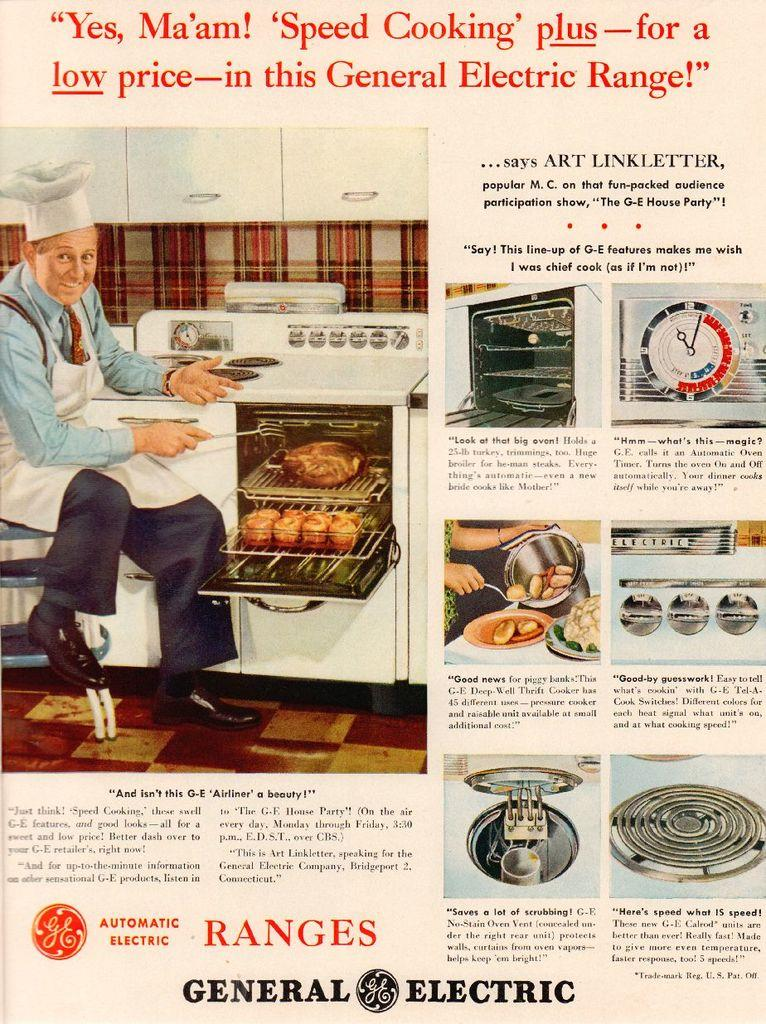<image>
Give a short and clear explanation of the subsequent image. Page from an advertisement which says "General Electric" on the bottom. 